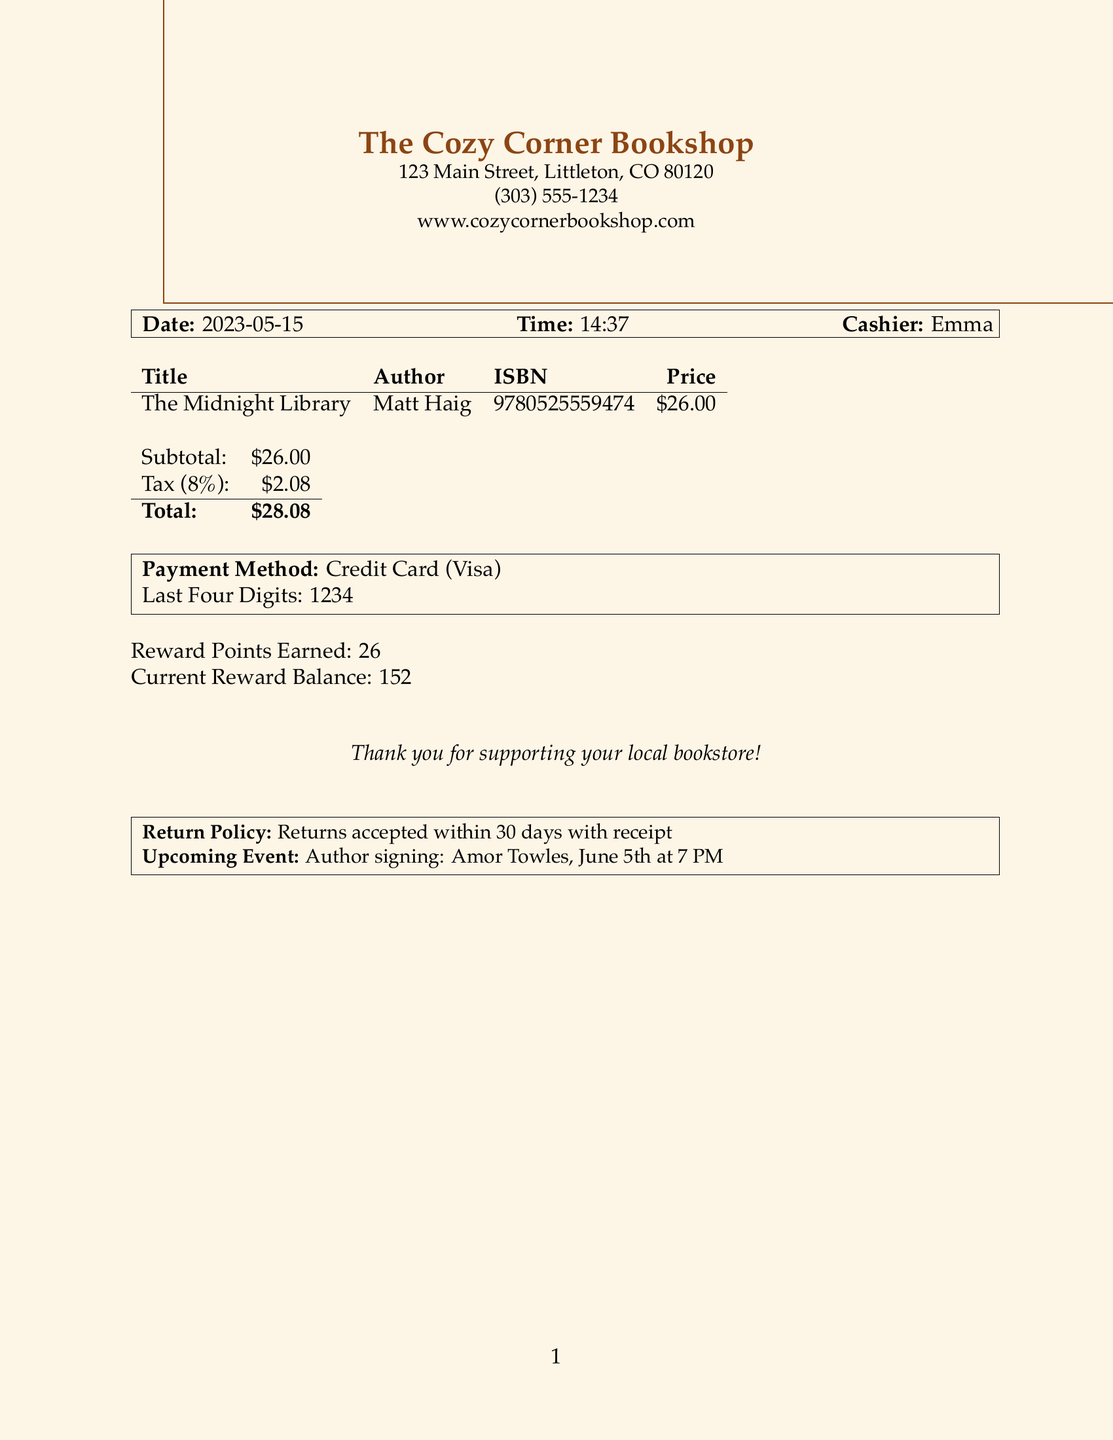What is the store name? The store name is listed at the top of the receipt.
Answer: The Cozy Corner Bookshop What is the author of the book? The author's name is provided in the itemized section of the receipt.
Answer: Matt Haig What is the price of the book? The price is shown in the itemized section under the price column.
Answer: $26.00 When is the upcoming event? The upcoming event details are mentioned towards the bottom of the receipt.
Answer: June 5th at 7 PM What is the total amount paid? The total amount is calculated from the subtotal and tax, shown at the end of the receipt.
Answer: $28.08 What payment method was used? The payment method is noted in the receipt details.
Answer: Credit Card How much tax was charged? The tax amount is specified in the financial summary of the receipt.
Answer: $2.08 How many reward points were earned? The number of reward points is indicated underneath the payment method section.
Answer: 26 